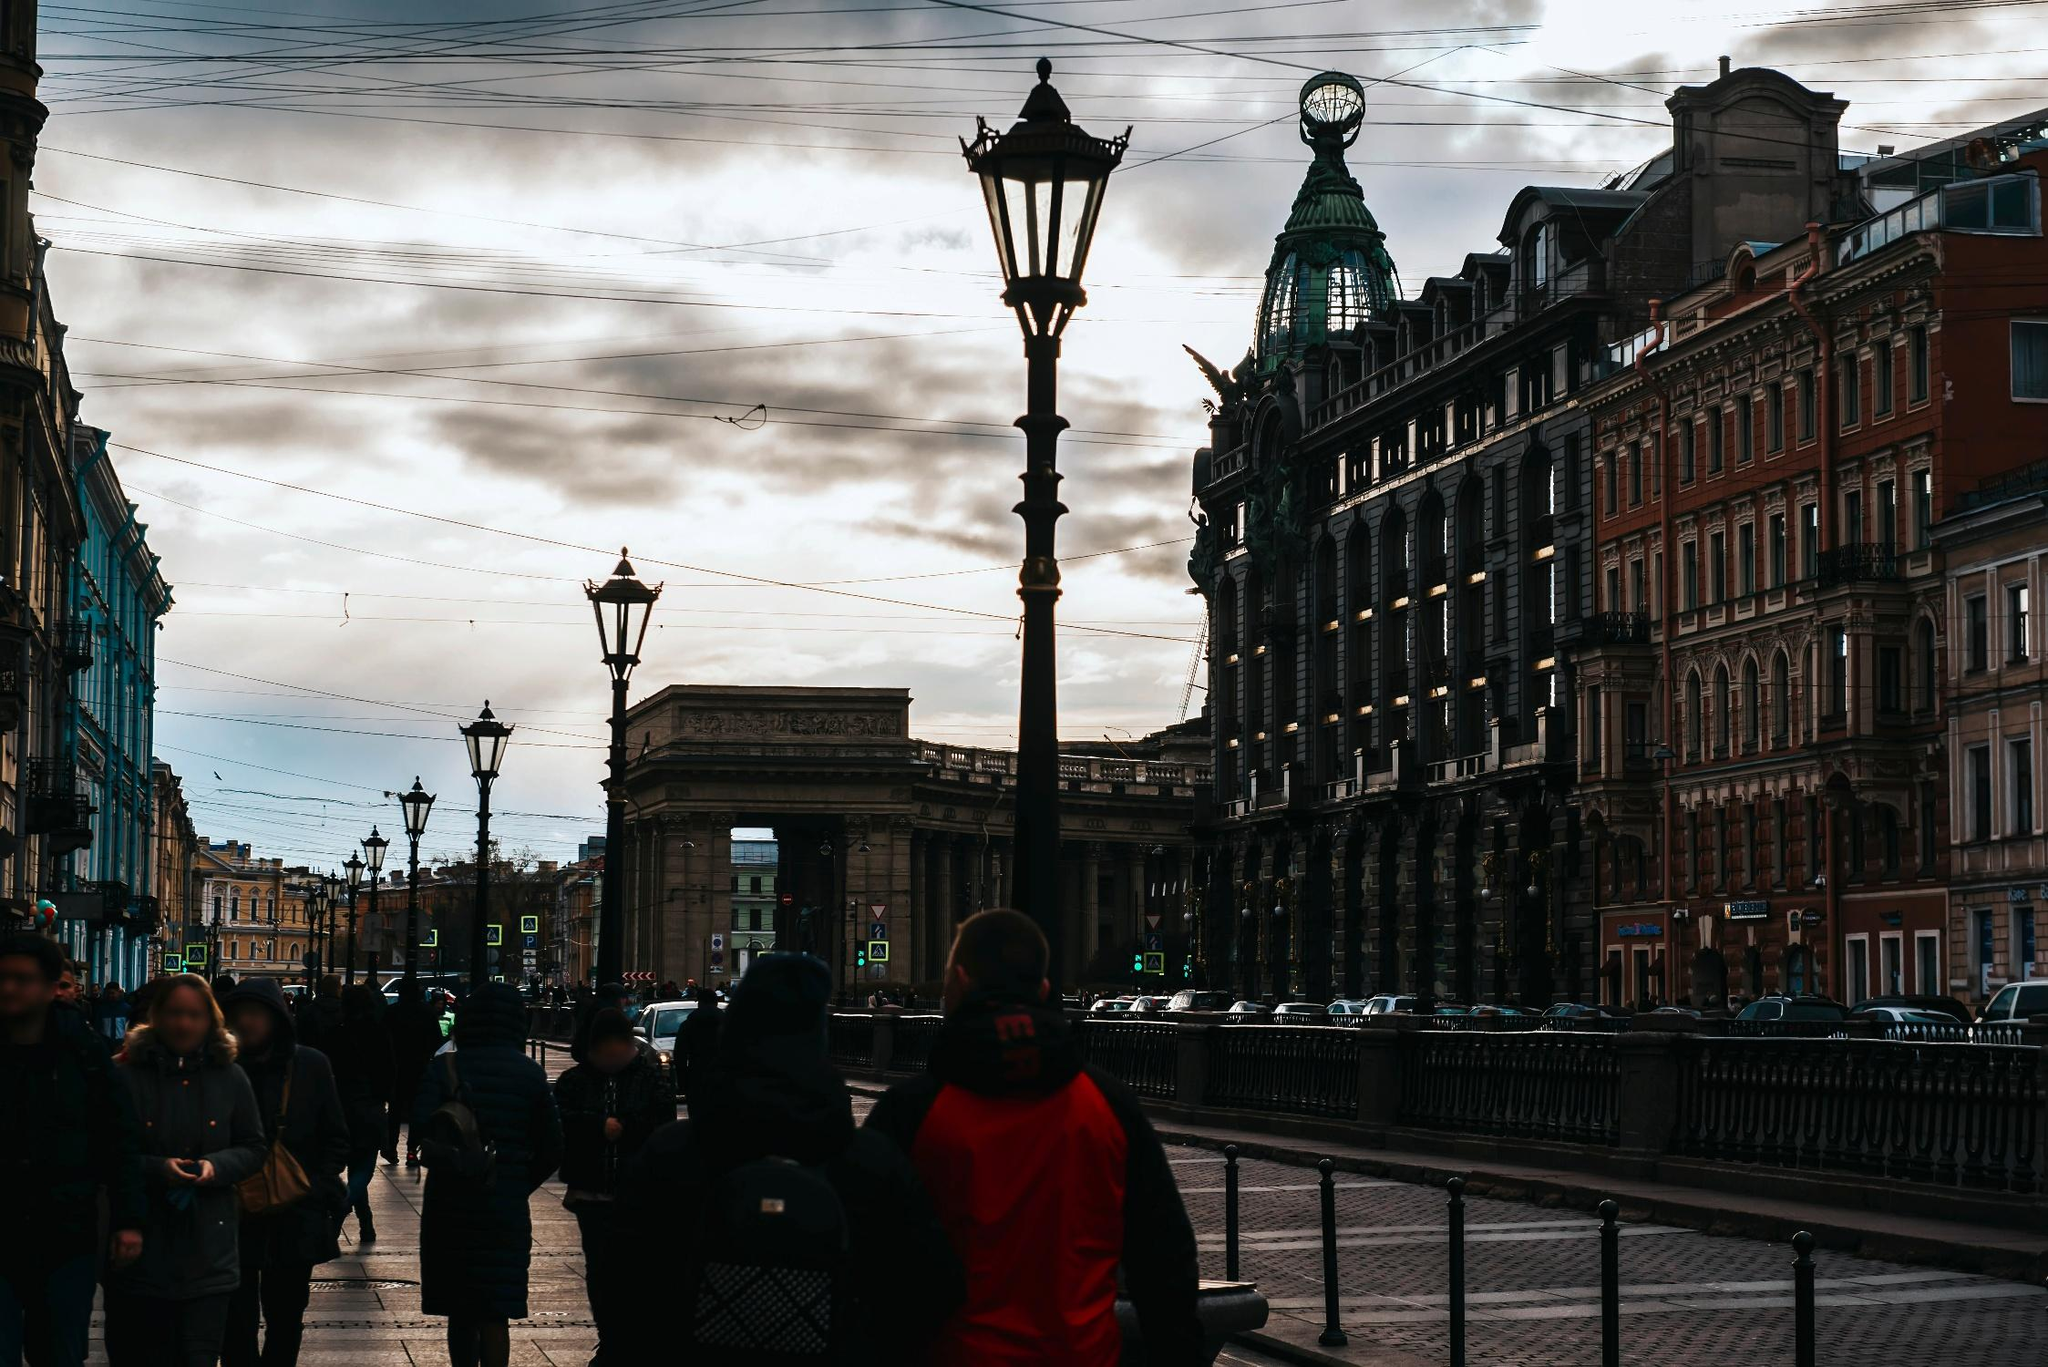What's happening in the scene? The image depicts a lively urban scene towards evening in what appears to be a European city, possibly in Russia, given the style of the architecture and the Cyrillic script on street signs. The avenue is bustling with people clad in warm clothing, suggesting a cool climate. Noteworthy is the historical architecture with ornate facades and large arches that add a classical charm to the setting. Electric tram lines are visible above, indicating a well-integrated public transportation system. As the day inches towards dusk, the diffuse light softens the scene, casting a tranquil yet vibrant atmosphere over the city life. 